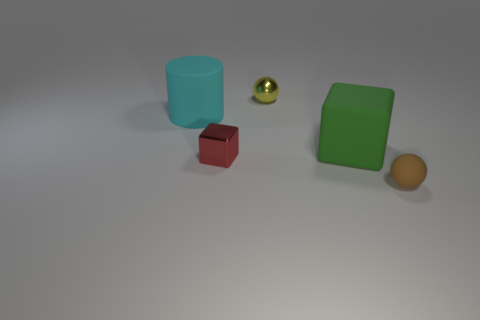Add 2 large red matte cylinders. How many objects exist? 7 Subtract all cylinders. How many objects are left? 4 Subtract all tiny purple shiny blocks. Subtract all small shiny spheres. How many objects are left? 4 Add 4 big rubber objects. How many big rubber objects are left? 6 Add 5 tiny brown spheres. How many tiny brown spheres exist? 6 Subtract 0 cyan balls. How many objects are left? 5 